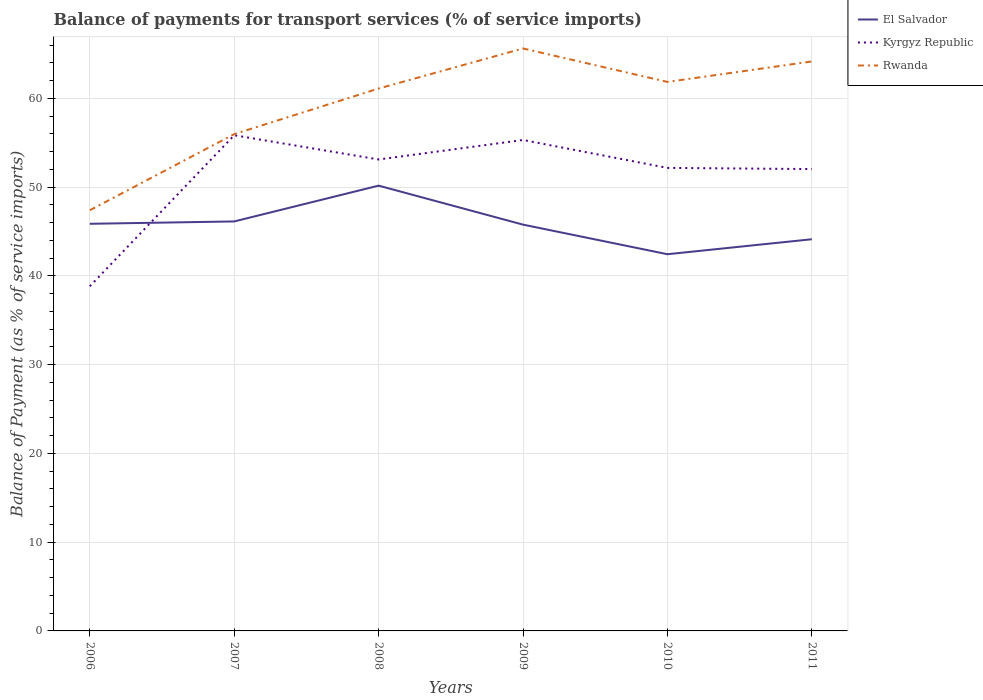How many different coloured lines are there?
Your answer should be very brief. 3. Across all years, what is the maximum balance of payments for transport services in Rwanda?
Provide a short and direct response. 47.4. What is the total balance of payments for transport services in Kyrgyz Republic in the graph?
Offer a very short reply. 3.28. What is the difference between the highest and the second highest balance of payments for transport services in El Salvador?
Your answer should be compact. 7.73. Are the values on the major ticks of Y-axis written in scientific E-notation?
Offer a very short reply. No. Does the graph contain grids?
Provide a succinct answer. Yes. Where does the legend appear in the graph?
Give a very brief answer. Top right. What is the title of the graph?
Your answer should be very brief. Balance of payments for transport services (% of service imports). What is the label or title of the X-axis?
Your answer should be compact. Years. What is the label or title of the Y-axis?
Offer a terse response. Balance of Payment (as % of service imports). What is the Balance of Payment (as % of service imports) in El Salvador in 2006?
Your response must be concise. 45.87. What is the Balance of Payment (as % of service imports) in Kyrgyz Republic in 2006?
Your answer should be compact. 38.83. What is the Balance of Payment (as % of service imports) in Rwanda in 2006?
Make the answer very short. 47.4. What is the Balance of Payment (as % of service imports) of El Salvador in 2007?
Give a very brief answer. 46.14. What is the Balance of Payment (as % of service imports) of Kyrgyz Republic in 2007?
Provide a succinct answer. 55.85. What is the Balance of Payment (as % of service imports) of Rwanda in 2007?
Offer a terse response. 55.98. What is the Balance of Payment (as % of service imports) of El Salvador in 2008?
Offer a very short reply. 50.17. What is the Balance of Payment (as % of service imports) of Kyrgyz Republic in 2008?
Offer a very short reply. 53.12. What is the Balance of Payment (as % of service imports) of Rwanda in 2008?
Give a very brief answer. 61.11. What is the Balance of Payment (as % of service imports) of El Salvador in 2009?
Provide a short and direct response. 45.78. What is the Balance of Payment (as % of service imports) of Kyrgyz Republic in 2009?
Offer a very short reply. 55.32. What is the Balance of Payment (as % of service imports) in Rwanda in 2009?
Offer a terse response. 65.63. What is the Balance of Payment (as % of service imports) of El Salvador in 2010?
Provide a succinct answer. 42.44. What is the Balance of Payment (as % of service imports) of Kyrgyz Republic in 2010?
Offer a terse response. 52.17. What is the Balance of Payment (as % of service imports) in Rwanda in 2010?
Provide a short and direct response. 61.86. What is the Balance of Payment (as % of service imports) in El Salvador in 2011?
Keep it short and to the point. 44.13. What is the Balance of Payment (as % of service imports) in Kyrgyz Republic in 2011?
Your answer should be compact. 52.04. What is the Balance of Payment (as % of service imports) in Rwanda in 2011?
Ensure brevity in your answer.  64.16. Across all years, what is the maximum Balance of Payment (as % of service imports) in El Salvador?
Provide a short and direct response. 50.17. Across all years, what is the maximum Balance of Payment (as % of service imports) of Kyrgyz Republic?
Provide a short and direct response. 55.85. Across all years, what is the maximum Balance of Payment (as % of service imports) in Rwanda?
Your response must be concise. 65.63. Across all years, what is the minimum Balance of Payment (as % of service imports) of El Salvador?
Your answer should be compact. 42.44. Across all years, what is the minimum Balance of Payment (as % of service imports) of Kyrgyz Republic?
Make the answer very short. 38.83. Across all years, what is the minimum Balance of Payment (as % of service imports) in Rwanda?
Offer a very short reply. 47.4. What is the total Balance of Payment (as % of service imports) of El Salvador in the graph?
Keep it short and to the point. 274.54. What is the total Balance of Payment (as % of service imports) of Kyrgyz Republic in the graph?
Your response must be concise. 307.33. What is the total Balance of Payment (as % of service imports) in Rwanda in the graph?
Offer a very short reply. 356.14. What is the difference between the Balance of Payment (as % of service imports) in El Salvador in 2006 and that in 2007?
Give a very brief answer. -0.27. What is the difference between the Balance of Payment (as % of service imports) of Kyrgyz Republic in 2006 and that in 2007?
Your answer should be compact. -17.02. What is the difference between the Balance of Payment (as % of service imports) of Rwanda in 2006 and that in 2007?
Make the answer very short. -8.58. What is the difference between the Balance of Payment (as % of service imports) of El Salvador in 2006 and that in 2008?
Your answer should be very brief. -4.3. What is the difference between the Balance of Payment (as % of service imports) of Kyrgyz Republic in 2006 and that in 2008?
Make the answer very short. -14.29. What is the difference between the Balance of Payment (as % of service imports) in Rwanda in 2006 and that in 2008?
Your response must be concise. -13.72. What is the difference between the Balance of Payment (as % of service imports) in El Salvador in 2006 and that in 2009?
Offer a terse response. 0.09. What is the difference between the Balance of Payment (as % of service imports) of Kyrgyz Republic in 2006 and that in 2009?
Give a very brief answer. -16.48. What is the difference between the Balance of Payment (as % of service imports) of Rwanda in 2006 and that in 2009?
Your response must be concise. -18.23. What is the difference between the Balance of Payment (as % of service imports) in El Salvador in 2006 and that in 2010?
Give a very brief answer. 3.43. What is the difference between the Balance of Payment (as % of service imports) of Kyrgyz Republic in 2006 and that in 2010?
Your answer should be compact. -13.34. What is the difference between the Balance of Payment (as % of service imports) of Rwanda in 2006 and that in 2010?
Offer a terse response. -14.46. What is the difference between the Balance of Payment (as % of service imports) of El Salvador in 2006 and that in 2011?
Make the answer very short. 1.74. What is the difference between the Balance of Payment (as % of service imports) in Kyrgyz Republic in 2006 and that in 2011?
Ensure brevity in your answer.  -13.21. What is the difference between the Balance of Payment (as % of service imports) in Rwanda in 2006 and that in 2011?
Keep it short and to the point. -16.77. What is the difference between the Balance of Payment (as % of service imports) in El Salvador in 2007 and that in 2008?
Offer a very short reply. -4.03. What is the difference between the Balance of Payment (as % of service imports) of Kyrgyz Republic in 2007 and that in 2008?
Offer a very short reply. 2.73. What is the difference between the Balance of Payment (as % of service imports) in Rwanda in 2007 and that in 2008?
Your answer should be compact. -5.14. What is the difference between the Balance of Payment (as % of service imports) in El Salvador in 2007 and that in 2009?
Give a very brief answer. 0.36. What is the difference between the Balance of Payment (as % of service imports) of Kyrgyz Republic in 2007 and that in 2009?
Your answer should be compact. 0.53. What is the difference between the Balance of Payment (as % of service imports) in Rwanda in 2007 and that in 2009?
Ensure brevity in your answer.  -9.65. What is the difference between the Balance of Payment (as % of service imports) of El Salvador in 2007 and that in 2010?
Offer a terse response. 3.69. What is the difference between the Balance of Payment (as % of service imports) in Kyrgyz Republic in 2007 and that in 2010?
Your response must be concise. 3.68. What is the difference between the Balance of Payment (as % of service imports) of Rwanda in 2007 and that in 2010?
Your response must be concise. -5.88. What is the difference between the Balance of Payment (as % of service imports) of El Salvador in 2007 and that in 2011?
Your answer should be compact. 2.01. What is the difference between the Balance of Payment (as % of service imports) in Kyrgyz Republic in 2007 and that in 2011?
Your answer should be compact. 3.81. What is the difference between the Balance of Payment (as % of service imports) in Rwanda in 2007 and that in 2011?
Your answer should be very brief. -8.19. What is the difference between the Balance of Payment (as % of service imports) of El Salvador in 2008 and that in 2009?
Offer a terse response. 4.39. What is the difference between the Balance of Payment (as % of service imports) of Kyrgyz Republic in 2008 and that in 2009?
Make the answer very short. -2.19. What is the difference between the Balance of Payment (as % of service imports) in Rwanda in 2008 and that in 2009?
Ensure brevity in your answer.  -4.51. What is the difference between the Balance of Payment (as % of service imports) of El Salvador in 2008 and that in 2010?
Provide a succinct answer. 7.73. What is the difference between the Balance of Payment (as % of service imports) of Kyrgyz Republic in 2008 and that in 2010?
Ensure brevity in your answer.  0.95. What is the difference between the Balance of Payment (as % of service imports) in Rwanda in 2008 and that in 2010?
Keep it short and to the point. -0.74. What is the difference between the Balance of Payment (as % of service imports) of El Salvador in 2008 and that in 2011?
Make the answer very short. 6.04. What is the difference between the Balance of Payment (as % of service imports) in Kyrgyz Republic in 2008 and that in 2011?
Give a very brief answer. 1.08. What is the difference between the Balance of Payment (as % of service imports) of Rwanda in 2008 and that in 2011?
Make the answer very short. -3.05. What is the difference between the Balance of Payment (as % of service imports) in El Salvador in 2009 and that in 2010?
Your answer should be compact. 3.33. What is the difference between the Balance of Payment (as % of service imports) of Kyrgyz Republic in 2009 and that in 2010?
Provide a succinct answer. 3.15. What is the difference between the Balance of Payment (as % of service imports) of Rwanda in 2009 and that in 2010?
Offer a very short reply. 3.77. What is the difference between the Balance of Payment (as % of service imports) in El Salvador in 2009 and that in 2011?
Keep it short and to the point. 1.65. What is the difference between the Balance of Payment (as % of service imports) in Kyrgyz Republic in 2009 and that in 2011?
Your answer should be very brief. 3.28. What is the difference between the Balance of Payment (as % of service imports) of Rwanda in 2009 and that in 2011?
Make the answer very short. 1.46. What is the difference between the Balance of Payment (as % of service imports) in El Salvador in 2010 and that in 2011?
Give a very brief answer. -1.69. What is the difference between the Balance of Payment (as % of service imports) of Kyrgyz Republic in 2010 and that in 2011?
Ensure brevity in your answer.  0.13. What is the difference between the Balance of Payment (as % of service imports) in Rwanda in 2010 and that in 2011?
Your answer should be compact. -2.31. What is the difference between the Balance of Payment (as % of service imports) of El Salvador in 2006 and the Balance of Payment (as % of service imports) of Kyrgyz Republic in 2007?
Keep it short and to the point. -9.98. What is the difference between the Balance of Payment (as % of service imports) in El Salvador in 2006 and the Balance of Payment (as % of service imports) in Rwanda in 2007?
Offer a very short reply. -10.1. What is the difference between the Balance of Payment (as % of service imports) in Kyrgyz Republic in 2006 and the Balance of Payment (as % of service imports) in Rwanda in 2007?
Your answer should be compact. -17.14. What is the difference between the Balance of Payment (as % of service imports) in El Salvador in 2006 and the Balance of Payment (as % of service imports) in Kyrgyz Republic in 2008?
Make the answer very short. -7.25. What is the difference between the Balance of Payment (as % of service imports) in El Salvador in 2006 and the Balance of Payment (as % of service imports) in Rwanda in 2008?
Offer a terse response. -15.24. What is the difference between the Balance of Payment (as % of service imports) in Kyrgyz Republic in 2006 and the Balance of Payment (as % of service imports) in Rwanda in 2008?
Offer a very short reply. -22.28. What is the difference between the Balance of Payment (as % of service imports) in El Salvador in 2006 and the Balance of Payment (as % of service imports) in Kyrgyz Republic in 2009?
Keep it short and to the point. -9.44. What is the difference between the Balance of Payment (as % of service imports) of El Salvador in 2006 and the Balance of Payment (as % of service imports) of Rwanda in 2009?
Your answer should be very brief. -19.76. What is the difference between the Balance of Payment (as % of service imports) in Kyrgyz Republic in 2006 and the Balance of Payment (as % of service imports) in Rwanda in 2009?
Your answer should be compact. -26.8. What is the difference between the Balance of Payment (as % of service imports) in El Salvador in 2006 and the Balance of Payment (as % of service imports) in Kyrgyz Republic in 2010?
Give a very brief answer. -6.3. What is the difference between the Balance of Payment (as % of service imports) in El Salvador in 2006 and the Balance of Payment (as % of service imports) in Rwanda in 2010?
Offer a very short reply. -15.99. What is the difference between the Balance of Payment (as % of service imports) in Kyrgyz Republic in 2006 and the Balance of Payment (as % of service imports) in Rwanda in 2010?
Make the answer very short. -23.03. What is the difference between the Balance of Payment (as % of service imports) of El Salvador in 2006 and the Balance of Payment (as % of service imports) of Kyrgyz Republic in 2011?
Provide a succinct answer. -6.17. What is the difference between the Balance of Payment (as % of service imports) of El Salvador in 2006 and the Balance of Payment (as % of service imports) of Rwanda in 2011?
Provide a short and direct response. -18.29. What is the difference between the Balance of Payment (as % of service imports) in Kyrgyz Republic in 2006 and the Balance of Payment (as % of service imports) in Rwanda in 2011?
Offer a terse response. -25.33. What is the difference between the Balance of Payment (as % of service imports) of El Salvador in 2007 and the Balance of Payment (as % of service imports) of Kyrgyz Republic in 2008?
Offer a terse response. -6.98. What is the difference between the Balance of Payment (as % of service imports) of El Salvador in 2007 and the Balance of Payment (as % of service imports) of Rwanda in 2008?
Provide a short and direct response. -14.98. What is the difference between the Balance of Payment (as % of service imports) of Kyrgyz Republic in 2007 and the Balance of Payment (as % of service imports) of Rwanda in 2008?
Offer a very short reply. -5.26. What is the difference between the Balance of Payment (as % of service imports) in El Salvador in 2007 and the Balance of Payment (as % of service imports) in Kyrgyz Republic in 2009?
Make the answer very short. -9.18. What is the difference between the Balance of Payment (as % of service imports) of El Salvador in 2007 and the Balance of Payment (as % of service imports) of Rwanda in 2009?
Keep it short and to the point. -19.49. What is the difference between the Balance of Payment (as % of service imports) in Kyrgyz Republic in 2007 and the Balance of Payment (as % of service imports) in Rwanda in 2009?
Provide a short and direct response. -9.78. What is the difference between the Balance of Payment (as % of service imports) of El Salvador in 2007 and the Balance of Payment (as % of service imports) of Kyrgyz Republic in 2010?
Make the answer very short. -6.03. What is the difference between the Balance of Payment (as % of service imports) of El Salvador in 2007 and the Balance of Payment (as % of service imports) of Rwanda in 2010?
Your response must be concise. -15.72. What is the difference between the Balance of Payment (as % of service imports) of Kyrgyz Republic in 2007 and the Balance of Payment (as % of service imports) of Rwanda in 2010?
Offer a very short reply. -6.01. What is the difference between the Balance of Payment (as % of service imports) of El Salvador in 2007 and the Balance of Payment (as % of service imports) of Kyrgyz Republic in 2011?
Offer a terse response. -5.9. What is the difference between the Balance of Payment (as % of service imports) in El Salvador in 2007 and the Balance of Payment (as % of service imports) in Rwanda in 2011?
Make the answer very short. -18.03. What is the difference between the Balance of Payment (as % of service imports) in Kyrgyz Republic in 2007 and the Balance of Payment (as % of service imports) in Rwanda in 2011?
Provide a short and direct response. -8.31. What is the difference between the Balance of Payment (as % of service imports) of El Salvador in 2008 and the Balance of Payment (as % of service imports) of Kyrgyz Republic in 2009?
Make the answer very short. -5.14. What is the difference between the Balance of Payment (as % of service imports) of El Salvador in 2008 and the Balance of Payment (as % of service imports) of Rwanda in 2009?
Make the answer very short. -15.46. What is the difference between the Balance of Payment (as % of service imports) in Kyrgyz Republic in 2008 and the Balance of Payment (as % of service imports) in Rwanda in 2009?
Your answer should be compact. -12.51. What is the difference between the Balance of Payment (as % of service imports) of El Salvador in 2008 and the Balance of Payment (as % of service imports) of Kyrgyz Republic in 2010?
Your response must be concise. -2. What is the difference between the Balance of Payment (as % of service imports) in El Salvador in 2008 and the Balance of Payment (as % of service imports) in Rwanda in 2010?
Offer a very short reply. -11.69. What is the difference between the Balance of Payment (as % of service imports) in Kyrgyz Republic in 2008 and the Balance of Payment (as % of service imports) in Rwanda in 2010?
Give a very brief answer. -8.74. What is the difference between the Balance of Payment (as % of service imports) in El Salvador in 2008 and the Balance of Payment (as % of service imports) in Kyrgyz Republic in 2011?
Provide a succinct answer. -1.87. What is the difference between the Balance of Payment (as % of service imports) of El Salvador in 2008 and the Balance of Payment (as % of service imports) of Rwanda in 2011?
Your response must be concise. -13.99. What is the difference between the Balance of Payment (as % of service imports) in Kyrgyz Republic in 2008 and the Balance of Payment (as % of service imports) in Rwanda in 2011?
Provide a succinct answer. -11.04. What is the difference between the Balance of Payment (as % of service imports) in El Salvador in 2009 and the Balance of Payment (as % of service imports) in Kyrgyz Republic in 2010?
Offer a very short reply. -6.39. What is the difference between the Balance of Payment (as % of service imports) of El Salvador in 2009 and the Balance of Payment (as % of service imports) of Rwanda in 2010?
Make the answer very short. -16.08. What is the difference between the Balance of Payment (as % of service imports) of Kyrgyz Republic in 2009 and the Balance of Payment (as % of service imports) of Rwanda in 2010?
Give a very brief answer. -6.54. What is the difference between the Balance of Payment (as % of service imports) of El Salvador in 2009 and the Balance of Payment (as % of service imports) of Kyrgyz Republic in 2011?
Your response must be concise. -6.26. What is the difference between the Balance of Payment (as % of service imports) in El Salvador in 2009 and the Balance of Payment (as % of service imports) in Rwanda in 2011?
Your response must be concise. -18.39. What is the difference between the Balance of Payment (as % of service imports) in Kyrgyz Republic in 2009 and the Balance of Payment (as % of service imports) in Rwanda in 2011?
Your response must be concise. -8.85. What is the difference between the Balance of Payment (as % of service imports) in El Salvador in 2010 and the Balance of Payment (as % of service imports) in Kyrgyz Republic in 2011?
Your response must be concise. -9.59. What is the difference between the Balance of Payment (as % of service imports) in El Salvador in 2010 and the Balance of Payment (as % of service imports) in Rwanda in 2011?
Keep it short and to the point. -21.72. What is the difference between the Balance of Payment (as % of service imports) in Kyrgyz Republic in 2010 and the Balance of Payment (as % of service imports) in Rwanda in 2011?
Your answer should be compact. -11.99. What is the average Balance of Payment (as % of service imports) of El Salvador per year?
Keep it short and to the point. 45.76. What is the average Balance of Payment (as % of service imports) in Kyrgyz Republic per year?
Provide a succinct answer. 51.22. What is the average Balance of Payment (as % of service imports) in Rwanda per year?
Your answer should be very brief. 59.36. In the year 2006, what is the difference between the Balance of Payment (as % of service imports) of El Salvador and Balance of Payment (as % of service imports) of Kyrgyz Republic?
Your answer should be compact. 7.04. In the year 2006, what is the difference between the Balance of Payment (as % of service imports) of El Salvador and Balance of Payment (as % of service imports) of Rwanda?
Offer a terse response. -1.53. In the year 2006, what is the difference between the Balance of Payment (as % of service imports) of Kyrgyz Republic and Balance of Payment (as % of service imports) of Rwanda?
Provide a succinct answer. -8.57. In the year 2007, what is the difference between the Balance of Payment (as % of service imports) in El Salvador and Balance of Payment (as % of service imports) in Kyrgyz Republic?
Your answer should be compact. -9.71. In the year 2007, what is the difference between the Balance of Payment (as % of service imports) in El Salvador and Balance of Payment (as % of service imports) in Rwanda?
Ensure brevity in your answer.  -9.84. In the year 2007, what is the difference between the Balance of Payment (as % of service imports) in Kyrgyz Republic and Balance of Payment (as % of service imports) in Rwanda?
Offer a terse response. -0.13. In the year 2008, what is the difference between the Balance of Payment (as % of service imports) in El Salvador and Balance of Payment (as % of service imports) in Kyrgyz Republic?
Keep it short and to the point. -2.95. In the year 2008, what is the difference between the Balance of Payment (as % of service imports) in El Salvador and Balance of Payment (as % of service imports) in Rwanda?
Your answer should be very brief. -10.94. In the year 2008, what is the difference between the Balance of Payment (as % of service imports) of Kyrgyz Republic and Balance of Payment (as % of service imports) of Rwanda?
Offer a terse response. -7.99. In the year 2009, what is the difference between the Balance of Payment (as % of service imports) in El Salvador and Balance of Payment (as % of service imports) in Kyrgyz Republic?
Give a very brief answer. -9.54. In the year 2009, what is the difference between the Balance of Payment (as % of service imports) of El Salvador and Balance of Payment (as % of service imports) of Rwanda?
Offer a terse response. -19.85. In the year 2009, what is the difference between the Balance of Payment (as % of service imports) in Kyrgyz Republic and Balance of Payment (as % of service imports) in Rwanda?
Your response must be concise. -10.31. In the year 2010, what is the difference between the Balance of Payment (as % of service imports) in El Salvador and Balance of Payment (as % of service imports) in Kyrgyz Republic?
Give a very brief answer. -9.73. In the year 2010, what is the difference between the Balance of Payment (as % of service imports) in El Salvador and Balance of Payment (as % of service imports) in Rwanda?
Provide a short and direct response. -19.41. In the year 2010, what is the difference between the Balance of Payment (as % of service imports) of Kyrgyz Republic and Balance of Payment (as % of service imports) of Rwanda?
Offer a very short reply. -9.69. In the year 2011, what is the difference between the Balance of Payment (as % of service imports) in El Salvador and Balance of Payment (as % of service imports) in Kyrgyz Republic?
Make the answer very short. -7.91. In the year 2011, what is the difference between the Balance of Payment (as % of service imports) of El Salvador and Balance of Payment (as % of service imports) of Rwanda?
Provide a short and direct response. -20.03. In the year 2011, what is the difference between the Balance of Payment (as % of service imports) of Kyrgyz Republic and Balance of Payment (as % of service imports) of Rwanda?
Your response must be concise. -12.13. What is the ratio of the Balance of Payment (as % of service imports) in El Salvador in 2006 to that in 2007?
Provide a succinct answer. 0.99. What is the ratio of the Balance of Payment (as % of service imports) in Kyrgyz Republic in 2006 to that in 2007?
Ensure brevity in your answer.  0.7. What is the ratio of the Balance of Payment (as % of service imports) in Rwanda in 2006 to that in 2007?
Provide a succinct answer. 0.85. What is the ratio of the Balance of Payment (as % of service imports) in El Salvador in 2006 to that in 2008?
Ensure brevity in your answer.  0.91. What is the ratio of the Balance of Payment (as % of service imports) in Kyrgyz Republic in 2006 to that in 2008?
Provide a short and direct response. 0.73. What is the ratio of the Balance of Payment (as % of service imports) in Rwanda in 2006 to that in 2008?
Give a very brief answer. 0.78. What is the ratio of the Balance of Payment (as % of service imports) of Kyrgyz Republic in 2006 to that in 2009?
Your answer should be compact. 0.7. What is the ratio of the Balance of Payment (as % of service imports) in Rwanda in 2006 to that in 2009?
Offer a terse response. 0.72. What is the ratio of the Balance of Payment (as % of service imports) of El Salvador in 2006 to that in 2010?
Your response must be concise. 1.08. What is the ratio of the Balance of Payment (as % of service imports) of Kyrgyz Republic in 2006 to that in 2010?
Keep it short and to the point. 0.74. What is the ratio of the Balance of Payment (as % of service imports) in Rwanda in 2006 to that in 2010?
Offer a terse response. 0.77. What is the ratio of the Balance of Payment (as % of service imports) of El Salvador in 2006 to that in 2011?
Your answer should be very brief. 1.04. What is the ratio of the Balance of Payment (as % of service imports) of Kyrgyz Republic in 2006 to that in 2011?
Your answer should be compact. 0.75. What is the ratio of the Balance of Payment (as % of service imports) of Rwanda in 2006 to that in 2011?
Your response must be concise. 0.74. What is the ratio of the Balance of Payment (as % of service imports) in El Salvador in 2007 to that in 2008?
Offer a terse response. 0.92. What is the ratio of the Balance of Payment (as % of service imports) of Kyrgyz Republic in 2007 to that in 2008?
Provide a short and direct response. 1.05. What is the ratio of the Balance of Payment (as % of service imports) in Rwanda in 2007 to that in 2008?
Your answer should be compact. 0.92. What is the ratio of the Balance of Payment (as % of service imports) of Kyrgyz Republic in 2007 to that in 2009?
Keep it short and to the point. 1.01. What is the ratio of the Balance of Payment (as % of service imports) in Rwanda in 2007 to that in 2009?
Give a very brief answer. 0.85. What is the ratio of the Balance of Payment (as % of service imports) in El Salvador in 2007 to that in 2010?
Your answer should be very brief. 1.09. What is the ratio of the Balance of Payment (as % of service imports) in Kyrgyz Republic in 2007 to that in 2010?
Offer a very short reply. 1.07. What is the ratio of the Balance of Payment (as % of service imports) in Rwanda in 2007 to that in 2010?
Ensure brevity in your answer.  0.9. What is the ratio of the Balance of Payment (as % of service imports) in El Salvador in 2007 to that in 2011?
Make the answer very short. 1.05. What is the ratio of the Balance of Payment (as % of service imports) in Kyrgyz Republic in 2007 to that in 2011?
Offer a terse response. 1.07. What is the ratio of the Balance of Payment (as % of service imports) in Rwanda in 2007 to that in 2011?
Your answer should be compact. 0.87. What is the ratio of the Balance of Payment (as % of service imports) in El Salvador in 2008 to that in 2009?
Provide a succinct answer. 1.1. What is the ratio of the Balance of Payment (as % of service imports) in Kyrgyz Republic in 2008 to that in 2009?
Give a very brief answer. 0.96. What is the ratio of the Balance of Payment (as % of service imports) in Rwanda in 2008 to that in 2009?
Offer a very short reply. 0.93. What is the ratio of the Balance of Payment (as % of service imports) in El Salvador in 2008 to that in 2010?
Your response must be concise. 1.18. What is the ratio of the Balance of Payment (as % of service imports) in Kyrgyz Republic in 2008 to that in 2010?
Provide a short and direct response. 1.02. What is the ratio of the Balance of Payment (as % of service imports) in El Salvador in 2008 to that in 2011?
Your answer should be compact. 1.14. What is the ratio of the Balance of Payment (as % of service imports) of Kyrgyz Republic in 2008 to that in 2011?
Your answer should be compact. 1.02. What is the ratio of the Balance of Payment (as % of service imports) in Rwanda in 2008 to that in 2011?
Provide a succinct answer. 0.95. What is the ratio of the Balance of Payment (as % of service imports) of El Salvador in 2009 to that in 2010?
Provide a short and direct response. 1.08. What is the ratio of the Balance of Payment (as % of service imports) of Kyrgyz Republic in 2009 to that in 2010?
Give a very brief answer. 1.06. What is the ratio of the Balance of Payment (as % of service imports) of Rwanda in 2009 to that in 2010?
Make the answer very short. 1.06. What is the ratio of the Balance of Payment (as % of service imports) of El Salvador in 2009 to that in 2011?
Provide a short and direct response. 1.04. What is the ratio of the Balance of Payment (as % of service imports) of Kyrgyz Republic in 2009 to that in 2011?
Give a very brief answer. 1.06. What is the ratio of the Balance of Payment (as % of service imports) of Rwanda in 2009 to that in 2011?
Your answer should be compact. 1.02. What is the ratio of the Balance of Payment (as % of service imports) of El Salvador in 2010 to that in 2011?
Give a very brief answer. 0.96. What is the ratio of the Balance of Payment (as % of service imports) in Rwanda in 2010 to that in 2011?
Give a very brief answer. 0.96. What is the difference between the highest and the second highest Balance of Payment (as % of service imports) in El Salvador?
Offer a terse response. 4.03. What is the difference between the highest and the second highest Balance of Payment (as % of service imports) of Kyrgyz Republic?
Provide a short and direct response. 0.53. What is the difference between the highest and the second highest Balance of Payment (as % of service imports) of Rwanda?
Make the answer very short. 1.46. What is the difference between the highest and the lowest Balance of Payment (as % of service imports) in El Salvador?
Give a very brief answer. 7.73. What is the difference between the highest and the lowest Balance of Payment (as % of service imports) of Kyrgyz Republic?
Offer a terse response. 17.02. What is the difference between the highest and the lowest Balance of Payment (as % of service imports) of Rwanda?
Ensure brevity in your answer.  18.23. 